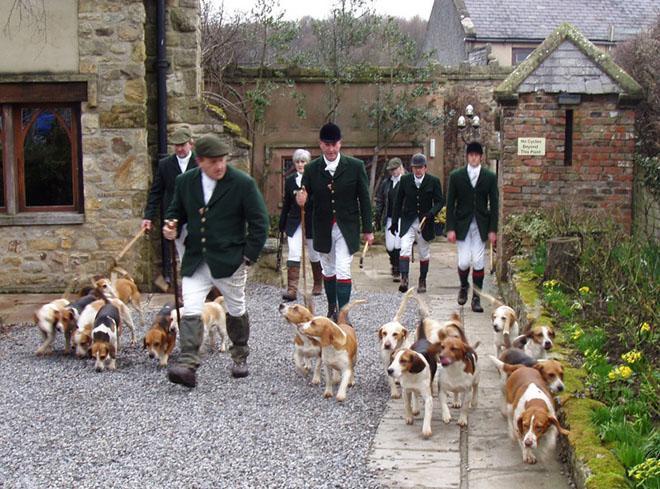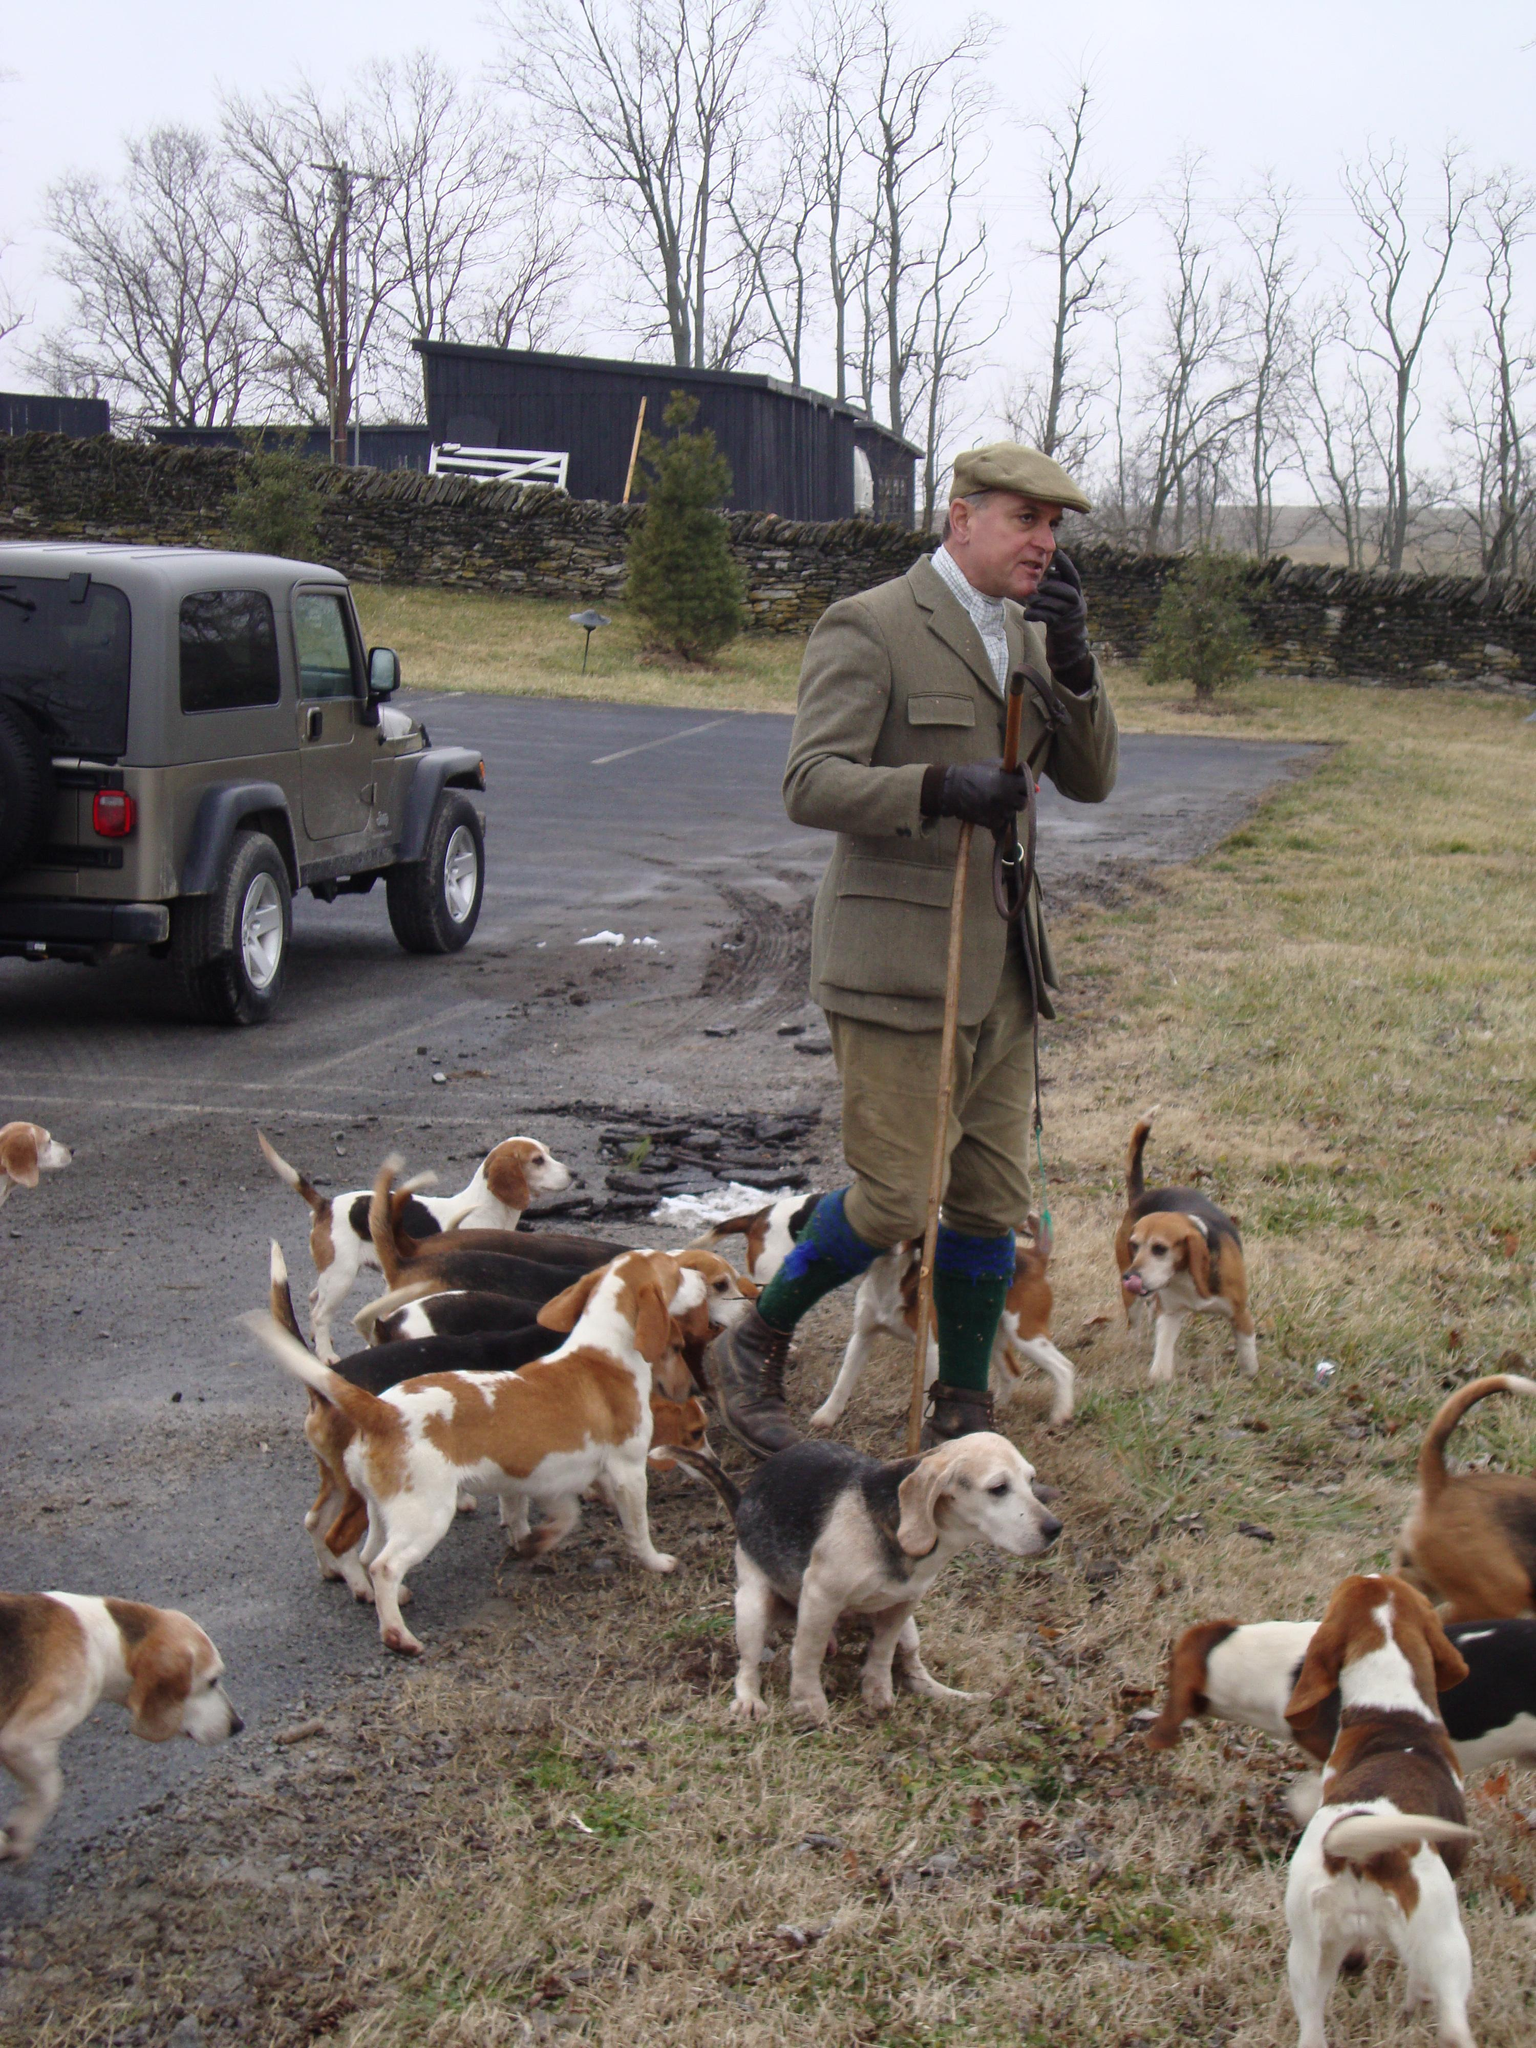The first image is the image on the left, the second image is the image on the right. Assess this claim about the two images: "There are exactly two people in the image on the right.". Correct or not? Answer yes or no. No. The first image is the image on the left, the second image is the image on the right. For the images displayed, is the sentence "In one image, at least two people wearing hunting jackets with white breeches and black boots are on foot with a pack of hunting dogs." factually correct? Answer yes or no. Yes. The first image is the image on the left, the second image is the image on the right. For the images shown, is this caption "There are no people in one of the images." true? Answer yes or no. No. 